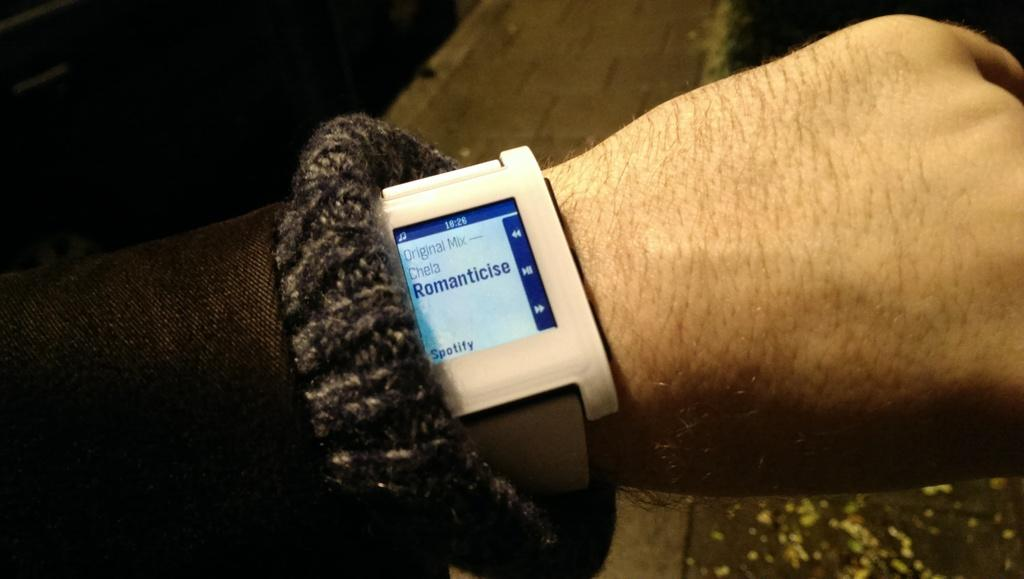Provide a one-sentence caption for the provided image. A man's wrist has a watch playing music from Spotify. 